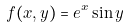<formula> <loc_0><loc_0><loc_500><loc_500>\, f ( x , y ) = e ^ { x } \sin y</formula> 